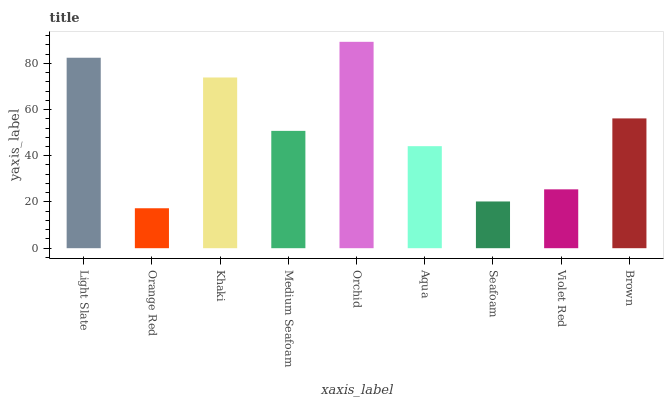Is Orange Red the minimum?
Answer yes or no. Yes. Is Orchid the maximum?
Answer yes or no. Yes. Is Khaki the minimum?
Answer yes or no. No. Is Khaki the maximum?
Answer yes or no. No. Is Khaki greater than Orange Red?
Answer yes or no. Yes. Is Orange Red less than Khaki?
Answer yes or no. Yes. Is Orange Red greater than Khaki?
Answer yes or no. No. Is Khaki less than Orange Red?
Answer yes or no. No. Is Medium Seafoam the high median?
Answer yes or no. Yes. Is Medium Seafoam the low median?
Answer yes or no. Yes. Is Violet Red the high median?
Answer yes or no. No. Is Seafoam the low median?
Answer yes or no. No. 